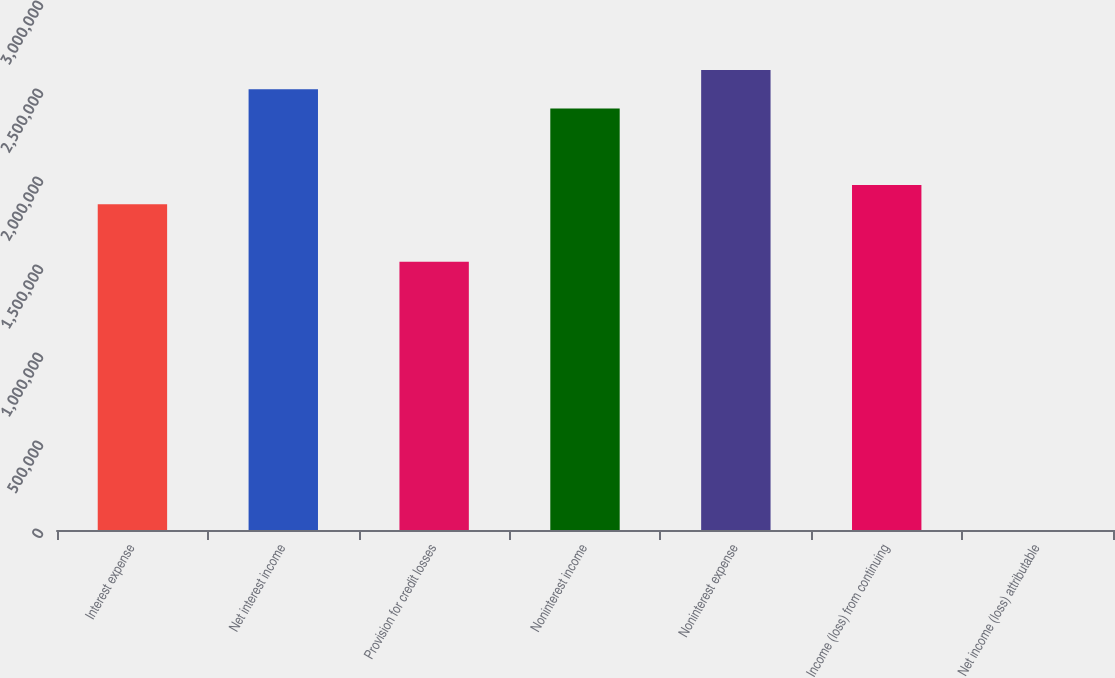Convert chart to OTSL. <chart><loc_0><loc_0><loc_500><loc_500><bar_chart><fcel>Interest expense<fcel>Net interest income<fcel>Provision for credit losses<fcel>Noninterest income<fcel>Noninterest expense<fcel>Income (loss) from continuing<fcel>Net income (loss) attributable<nl><fcel>1.85103e+06<fcel>2.50433e+06<fcel>1.52438e+06<fcel>2.39545e+06<fcel>2.61322e+06<fcel>1.95991e+06<fcel>0.32<nl></chart> 